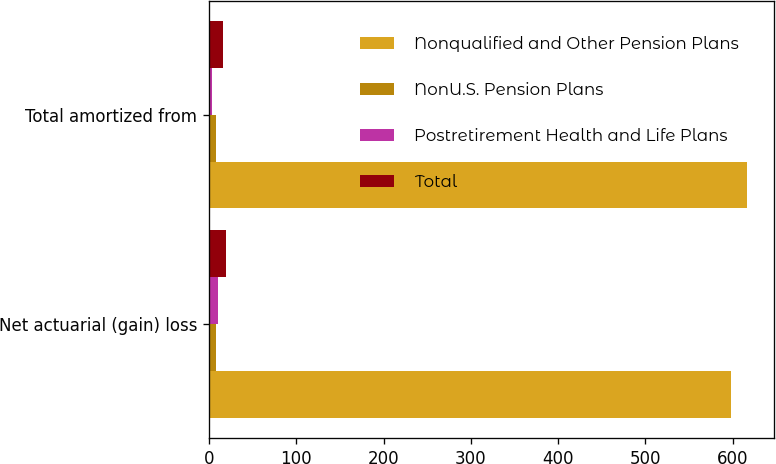Convert chart. <chart><loc_0><loc_0><loc_500><loc_500><stacked_bar_chart><ecel><fcel>Net actuarial (gain) loss<fcel>Total amortized from<nl><fcel>Nonqualified and Other Pension Plans<fcel>598<fcel>616<nl><fcel>NonU.S. Pension Plans<fcel>8<fcel>8<nl><fcel>Postretirement Health and Life Plans<fcel>10<fcel>3<nl><fcel>Total<fcel>19<fcel>16<nl></chart> 